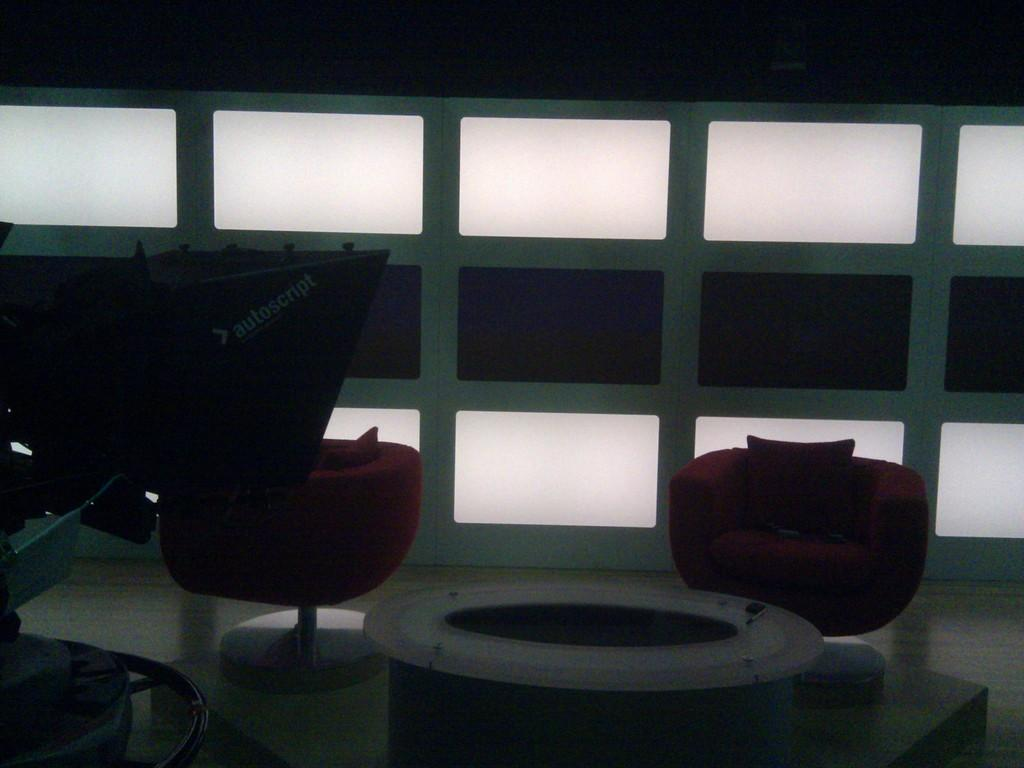How many chairs are in the room? There are two chairs in the room. What other furniture is present in the room? There is a table in the room. Can you describe any equipment or devices in the room? There appears to be a machine in the room. What type of lighting is present in the room? There are lights on the wall in the background. What type of property is visible in the room? There is no property visible in the room; the image only shows furniture and a machine. Can you describe the patch on the chair in the room? There is no patch mentioned or visible on the chairs in the room. 